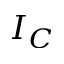<formula> <loc_0><loc_0><loc_500><loc_500>I _ { C }</formula> 